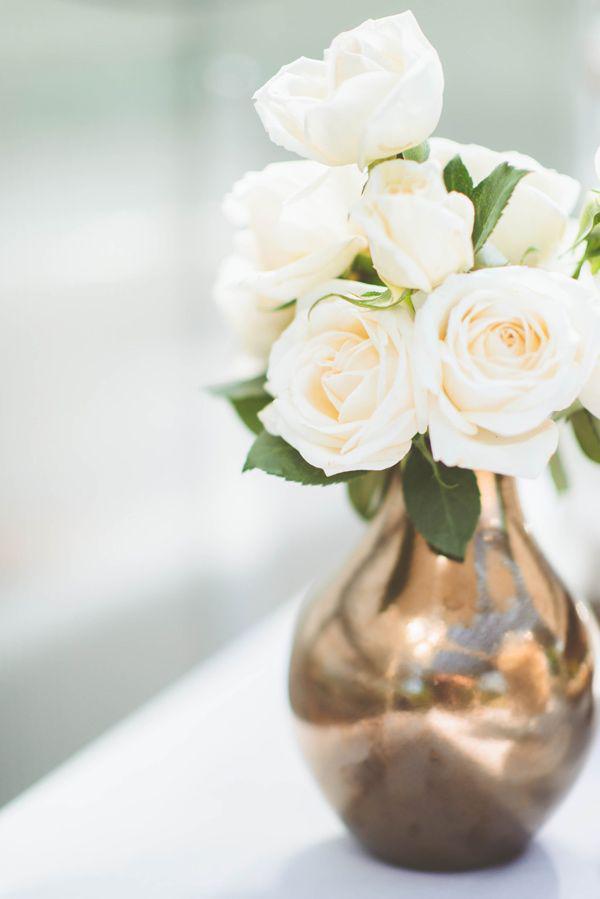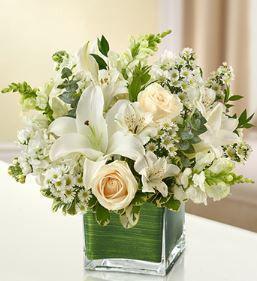The first image is the image on the left, the second image is the image on the right. Analyze the images presented: Is the assertion "There are multiple vases in the right image with the centre one the highest." valid? Answer yes or no. No. 